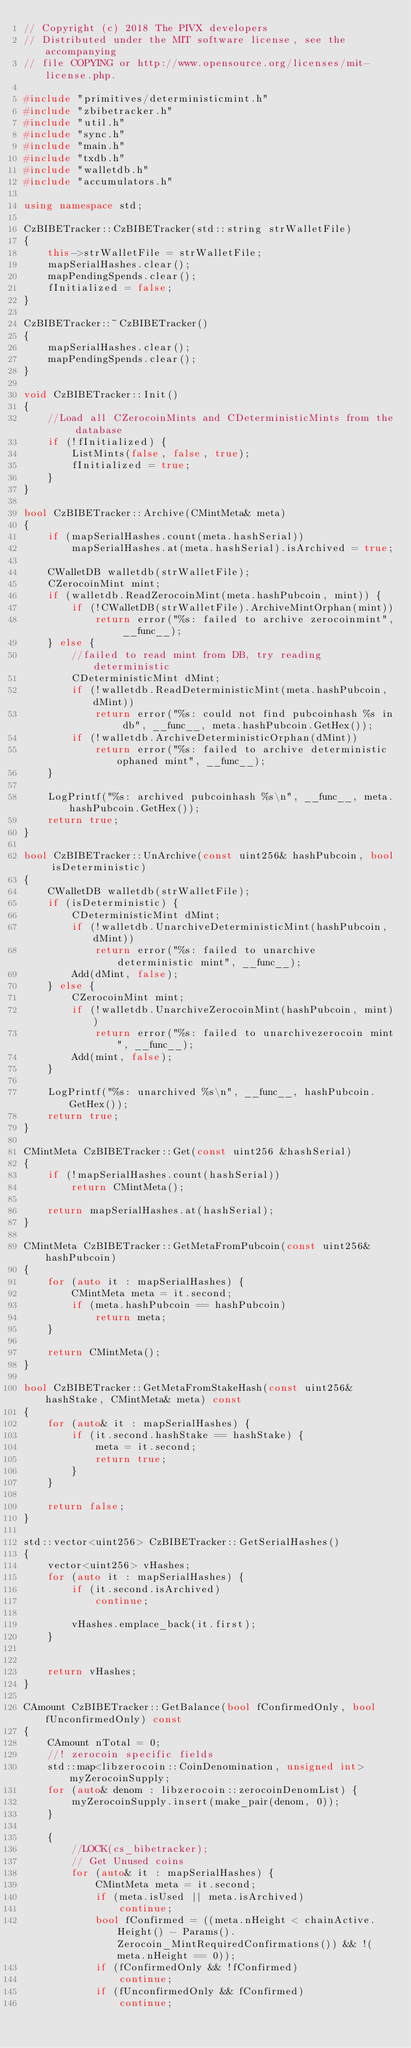Convert code to text. <code><loc_0><loc_0><loc_500><loc_500><_C++_>// Copyright (c) 2018 The PIVX developers
// Distributed under the MIT software license, see the accompanying
// file COPYING or http://www.opensource.org/licenses/mit-license.php.

#include "primitives/deterministicmint.h"
#include "zbibetracker.h"
#include "util.h"
#include "sync.h"
#include "main.h"
#include "txdb.h"
#include "walletdb.h"
#include "accumulators.h"

using namespace std;

CzBIBETracker::CzBIBETracker(std::string strWalletFile)
{
    this->strWalletFile = strWalletFile;
    mapSerialHashes.clear();
    mapPendingSpends.clear();
    fInitialized = false;
}

CzBIBETracker::~CzBIBETracker()
{
    mapSerialHashes.clear();
    mapPendingSpends.clear();
}

void CzBIBETracker::Init()
{
    //Load all CZerocoinMints and CDeterministicMints from the database
    if (!fInitialized) {
        ListMints(false, false, true);
        fInitialized = true;
    }
}

bool CzBIBETracker::Archive(CMintMeta& meta)
{
    if (mapSerialHashes.count(meta.hashSerial))
        mapSerialHashes.at(meta.hashSerial).isArchived = true;

    CWalletDB walletdb(strWalletFile);
    CZerocoinMint mint;
    if (walletdb.ReadZerocoinMint(meta.hashPubcoin, mint)) {
        if (!CWalletDB(strWalletFile).ArchiveMintOrphan(mint))
            return error("%s: failed to archive zerocoinmint", __func__);
    } else {
        //failed to read mint from DB, try reading deterministic
        CDeterministicMint dMint;
        if (!walletdb.ReadDeterministicMint(meta.hashPubcoin, dMint))
            return error("%s: could not find pubcoinhash %s in db", __func__, meta.hashPubcoin.GetHex());
        if (!walletdb.ArchiveDeterministicOrphan(dMint))
            return error("%s: failed to archive deterministic ophaned mint", __func__);
    }

    LogPrintf("%s: archived pubcoinhash %s\n", __func__, meta.hashPubcoin.GetHex());
    return true;
}

bool CzBIBETracker::UnArchive(const uint256& hashPubcoin, bool isDeterministic)
{
    CWalletDB walletdb(strWalletFile);
    if (isDeterministic) {
        CDeterministicMint dMint;
        if (!walletdb.UnarchiveDeterministicMint(hashPubcoin, dMint))
            return error("%s: failed to unarchive deterministic mint", __func__);
        Add(dMint, false);
    } else {
        CZerocoinMint mint;
        if (!walletdb.UnarchiveZerocoinMint(hashPubcoin, mint))
            return error("%s: failed to unarchivezerocoin mint", __func__);
        Add(mint, false);
    }

    LogPrintf("%s: unarchived %s\n", __func__, hashPubcoin.GetHex());
    return true;
}

CMintMeta CzBIBETracker::Get(const uint256 &hashSerial)
{
    if (!mapSerialHashes.count(hashSerial))
        return CMintMeta();

    return mapSerialHashes.at(hashSerial);
}

CMintMeta CzBIBETracker::GetMetaFromPubcoin(const uint256& hashPubcoin)
{
    for (auto it : mapSerialHashes) {
        CMintMeta meta = it.second;
        if (meta.hashPubcoin == hashPubcoin)
            return meta;
    }

    return CMintMeta();
}

bool CzBIBETracker::GetMetaFromStakeHash(const uint256& hashStake, CMintMeta& meta) const
{
    for (auto& it : mapSerialHashes) {
        if (it.second.hashStake == hashStake) {
            meta = it.second;
            return true;
        }
    }

    return false;
}

std::vector<uint256> CzBIBETracker::GetSerialHashes()
{
    vector<uint256> vHashes;
    for (auto it : mapSerialHashes) {
        if (it.second.isArchived)
            continue;

        vHashes.emplace_back(it.first);
    }


    return vHashes;
}

CAmount CzBIBETracker::GetBalance(bool fConfirmedOnly, bool fUnconfirmedOnly) const
{
    CAmount nTotal = 0;
    //! zerocoin specific fields
    std::map<libzerocoin::CoinDenomination, unsigned int> myZerocoinSupply;
    for (auto& denom : libzerocoin::zerocoinDenomList) {
        myZerocoinSupply.insert(make_pair(denom, 0));
    }

    {
        //LOCK(cs_bibetracker);
        // Get Unused coins
        for (auto& it : mapSerialHashes) {
            CMintMeta meta = it.second;
            if (meta.isUsed || meta.isArchived)
                continue;
            bool fConfirmed = ((meta.nHeight < chainActive.Height() - Params().Zerocoin_MintRequiredConfirmations()) && !(meta.nHeight == 0));
            if (fConfirmedOnly && !fConfirmed)
                continue;
            if (fUnconfirmedOnly && fConfirmed)
                continue;
</code> 